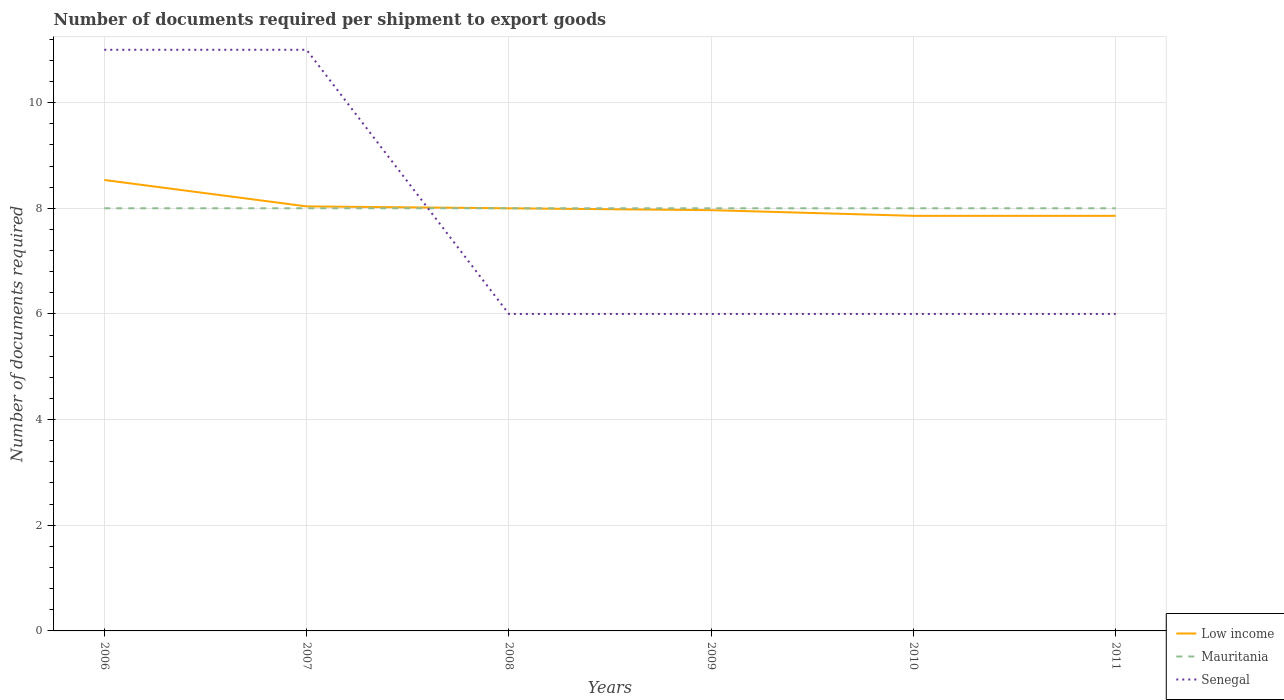How many different coloured lines are there?
Offer a very short reply. 3. Is the number of lines equal to the number of legend labels?
Your response must be concise. Yes. In which year was the number of documents required per shipment to export goods in Senegal maximum?
Provide a succinct answer. 2008. What is the total number of documents required per shipment to export goods in Low income in the graph?
Your answer should be very brief. 0.18. What is the difference between the highest and the second highest number of documents required per shipment to export goods in Mauritania?
Provide a short and direct response. 0. What is the difference between the highest and the lowest number of documents required per shipment to export goods in Senegal?
Offer a terse response. 2. Is the number of documents required per shipment to export goods in Low income strictly greater than the number of documents required per shipment to export goods in Senegal over the years?
Your response must be concise. No. Are the values on the major ticks of Y-axis written in scientific E-notation?
Keep it short and to the point. No. Does the graph contain any zero values?
Your response must be concise. No. Where does the legend appear in the graph?
Offer a very short reply. Bottom right. How are the legend labels stacked?
Ensure brevity in your answer.  Vertical. What is the title of the graph?
Make the answer very short. Number of documents required per shipment to export goods. Does "Luxembourg" appear as one of the legend labels in the graph?
Offer a terse response. No. What is the label or title of the X-axis?
Ensure brevity in your answer.  Years. What is the label or title of the Y-axis?
Keep it short and to the point. Number of documents required. What is the Number of documents required of Low income in 2006?
Provide a succinct answer. 8.54. What is the Number of documents required in Mauritania in 2006?
Offer a terse response. 8. What is the Number of documents required of Senegal in 2006?
Your answer should be compact. 11. What is the Number of documents required in Low income in 2007?
Provide a short and direct response. 8.04. What is the Number of documents required in Mauritania in 2008?
Your answer should be very brief. 8. What is the Number of documents required of Low income in 2009?
Offer a terse response. 7.96. What is the Number of documents required in Mauritania in 2009?
Offer a terse response. 8. What is the Number of documents required in Low income in 2010?
Ensure brevity in your answer.  7.86. What is the Number of documents required of Senegal in 2010?
Keep it short and to the point. 6. What is the Number of documents required in Low income in 2011?
Offer a terse response. 7.86. Across all years, what is the maximum Number of documents required in Low income?
Offer a very short reply. 8.54. Across all years, what is the maximum Number of documents required of Mauritania?
Your answer should be compact. 8. Across all years, what is the minimum Number of documents required of Low income?
Offer a very short reply. 7.86. Across all years, what is the minimum Number of documents required of Mauritania?
Your answer should be compact. 8. What is the total Number of documents required of Low income in the graph?
Make the answer very short. 48.25. What is the difference between the Number of documents required of Mauritania in 2006 and that in 2007?
Make the answer very short. 0. What is the difference between the Number of documents required in Senegal in 2006 and that in 2007?
Your answer should be compact. 0. What is the difference between the Number of documents required in Low income in 2006 and that in 2008?
Your answer should be compact. 0.54. What is the difference between the Number of documents required of Mauritania in 2006 and that in 2009?
Give a very brief answer. 0. What is the difference between the Number of documents required of Senegal in 2006 and that in 2009?
Your answer should be very brief. 5. What is the difference between the Number of documents required of Low income in 2006 and that in 2010?
Offer a very short reply. 0.68. What is the difference between the Number of documents required in Senegal in 2006 and that in 2010?
Give a very brief answer. 5. What is the difference between the Number of documents required in Low income in 2006 and that in 2011?
Give a very brief answer. 0.68. What is the difference between the Number of documents required in Mauritania in 2006 and that in 2011?
Offer a very short reply. 0. What is the difference between the Number of documents required in Low income in 2007 and that in 2008?
Keep it short and to the point. 0.04. What is the difference between the Number of documents required of Low income in 2007 and that in 2009?
Your answer should be compact. 0.07. What is the difference between the Number of documents required in Mauritania in 2007 and that in 2009?
Your answer should be compact. 0. What is the difference between the Number of documents required in Senegal in 2007 and that in 2009?
Your answer should be very brief. 5. What is the difference between the Number of documents required in Low income in 2007 and that in 2010?
Offer a terse response. 0.18. What is the difference between the Number of documents required of Mauritania in 2007 and that in 2010?
Your response must be concise. 0. What is the difference between the Number of documents required of Low income in 2007 and that in 2011?
Offer a terse response. 0.18. What is the difference between the Number of documents required in Senegal in 2007 and that in 2011?
Offer a very short reply. 5. What is the difference between the Number of documents required in Low income in 2008 and that in 2009?
Your response must be concise. 0.04. What is the difference between the Number of documents required of Low income in 2008 and that in 2010?
Your answer should be very brief. 0.14. What is the difference between the Number of documents required of Mauritania in 2008 and that in 2010?
Ensure brevity in your answer.  0. What is the difference between the Number of documents required in Senegal in 2008 and that in 2010?
Your answer should be very brief. 0. What is the difference between the Number of documents required of Low income in 2008 and that in 2011?
Provide a succinct answer. 0.14. What is the difference between the Number of documents required of Senegal in 2008 and that in 2011?
Make the answer very short. 0. What is the difference between the Number of documents required of Low income in 2009 and that in 2010?
Offer a terse response. 0.11. What is the difference between the Number of documents required in Mauritania in 2009 and that in 2010?
Ensure brevity in your answer.  0. What is the difference between the Number of documents required in Low income in 2009 and that in 2011?
Provide a succinct answer. 0.11. What is the difference between the Number of documents required in Mauritania in 2009 and that in 2011?
Ensure brevity in your answer.  0. What is the difference between the Number of documents required of Low income in 2010 and that in 2011?
Your answer should be very brief. 0. What is the difference between the Number of documents required in Mauritania in 2010 and that in 2011?
Give a very brief answer. 0. What is the difference between the Number of documents required in Low income in 2006 and the Number of documents required in Mauritania in 2007?
Make the answer very short. 0.54. What is the difference between the Number of documents required of Low income in 2006 and the Number of documents required of Senegal in 2007?
Give a very brief answer. -2.46. What is the difference between the Number of documents required of Mauritania in 2006 and the Number of documents required of Senegal in 2007?
Offer a terse response. -3. What is the difference between the Number of documents required of Low income in 2006 and the Number of documents required of Mauritania in 2008?
Offer a very short reply. 0.54. What is the difference between the Number of documents required in Low income in 2006 and the Number of documents required in Senegal in 2008?
Offer a terse response. 2.54. What is the difference between the Number of documents required in Low income in 2006 and the Number of documents required in Mauritania in 2009?
Ensure brevity in your answer.  0.54. What is the difference between the Number of documents required of Low income in 2006 and the Number of documents required of Senegal in 2009?
Provide a succinct answer. 2.54. What is the difference between the Number of documents required of Low income in 2006 and the Number of documents required of Mauritania in 2010?
Keep it short and to the point. 0.54. What is the difference between the Number of documents required of Low income in 2006 and the Number of documents required of Senegal in 2010?
Make the answer very short. 2.54. What is the difference between the Number of documents required in Low income in 2006 and the Number of documents required in Mauritania in 2011?
Your response must be concise. 0.54. What is the difference between the Number of documents required in Low income in 2006 and the Number of documents required in Senegal in 2011?
Your answer should be compact. 2.54. What is the difference between the Number of documents required in Low income in 2007 and the Number of documents required in Mauritania in 2008?
Your answer should be very brief. 0.04. What is the difference between the Number of documents required in Low income in 2007 and the Number of documents required in Senegal in 2008?
Ensure brevity in your answer.  2.04. What is the difference between the Number of documents required of Low income in 2007 and the Number of documents required of Mauritania in 2009?
Offer a terse response. 0.04. What is the difference between the Number of documents required of Low income in 2007 and the Number of documents required of Senegal in 2009?
Offer a terse response. 2.04. What is the difference between the Number of documents required in Low income in 2007 and the Number of documents required in Mauritania in 2010?
Make the answer very short. 0.04. What is the difference between the Number of documents required in Low income in 2007 and the Number of documents required in Senegal in 2010?
Offer a terse response. 2.04. What is the difference between the Number of documents required of Mauritania in 2007 and the Number of documents required of Senegal in 2010?
Give a very brief answer. 2. What is the difference between the Number of documents required of Low income in 2007 and the Number of documents required of Mauritania in 2011?
Keep it short and to the point. 0.04. What is the difference between the Number of documents required of Low income in 2007 and the Number of documents required of Senegal in 2011?
Your answer should be very brief. 2.04. What is the difference between the Number of documents required of Mauritania in 2007 and the Number of documents required of Senegal in 2011?
Keep it short and to the point. 2. What is the difference between the Number of documents required in Mauritania in 2008 and the Number of documents required in Senegal in 2009?
Keep it short and to the point. 2. What is the difference between the Number of documents required of Low income in 2008 and the Number of documents required of Mauritania in 2010?
Ensure brevity in your answer.  0. What is the difference between the Number of documents required in Low income in 2008 and the Number of documents required in Senegal in 2010?
Your answer should be compact. 2. What is the difference between the Number of documents required of Low income in 2008 and the Number of documents required of Senegal in 2011?
Provide a succinct answer. 2. What is the difference between the Number of documents required in Low income in 2009 and the Number of documents required in Mauritania in 2010?
Make the answer very short. -0.04. What is the difference between the Number of documents required of Low income in 2009 and the Number of documents required of Senegal in 2010?
Provide a succinct answer. 1.96. What is the difference between the Number of documents required of Low income in 2009 and the Number of documents required of Mauritania in 2011?
Your answer should be very brief. -0.04. What is the difference between the Number of documents required in Low income in 2009 and the Number of documents required in Senegal in 2011?
Offer a very short reply. 1.96. What is the difference between the Number of documents required in Low income in 2010 and the Number of documents required in Mauritania in 2011?
Give a very brief answer. -0.14. What is the difference between the Number of documents required in Low income in 2010 and the Number of documents required in Senegal in 2011?
Provide a succinct answer. 1.86. What is the difference between the Number of documents required of Mauritania in 2010 and the Number of documents required of Senegal in 2011?
Your response must be concise. 2. What is the average Number of documents required of Low income per year?
Offer a very short reply. 8.04. What is the average Number of documents required of Senegal per year?
Your response must be concise. 7.67. In the year 2006, what is the difference between the Number of documents required in Low income and Number of documents required in Mauritania?
Keep it short and to the point. 0.54. In the year 2006, what is the difference between the Number of documents required in Low income and Number of documents required in Senegal?
Keep it short and to the point. -2.46. In the year 2007, what is the difference between the Number of documents required of Low income and Number of documents required of Mauritania?
Offer a very short reply. 0.04. In the year 2007, what is the difference between the Number of documents required in Low income and Number of documents required in Senegal?
Give a very brief answer. -2.96. In the year 2007, what is the difference between the Number of documents required in Mauritania and Number of documents required in Senegal?
Your answer should be very brief. -3. In the year 2008, what is the difference between the Number of documents required of Low income and Number of documents required of Senegal?
Provide a succinct answer. 2. In the year 2009, what is the difference between the Number of documents required in Low income and Number of documents required in Mauritania?
Provide a succinct answer. -0.04. In the year 2009, what is the difference between the Number of documents required in Low income and Number of documents required in Senegal?
Provide a short and direct response. 1.96. In the year 2010, what is the difference between the Number of documents required of Low income and Number of documents required of Mauritania?
Ensure brevity in your answer.  -0.14. In the year 2010, what is the difference between the Number of documents required in Low income and Number of documents required in Senegal?
Provide a succinct answer. 1.86. In the year 2010, what is the difference between the Number of documents required of Mauritania and Number of documents required of Senegal?
Keep it short and to the point. 2. In the year 2011, what is the difference between the Number of documents required in Low income and Number of documents required in Mauritania?
Provide a short and direct response. -0.14. In the year 2011, what is the difference between the Number of documents required in Low income and Number of documents required in Senegal?
Ensure brevity in your answer.  1.86. What is the ratio of the Number of documents required of Low income in 2006 to that in 2007?
Offer a terse response. 1.06. What is the ratio of the Number of documents required of Mauritania in 2006 to that in 2007?
Keep it short and to the point. 1. What is the ratio of the Number of documents required in Low income in 2006 to that in 2008?
Offer a terse response. 1.07. What is the ratio of the Number of documents required in Mauritania in 2006 to that in 2008?
Make the answer very short. 1. What is the ratio of the Number of documents required of Senegal in 2006 to that in 2008?
Your response must be concise. 1.83. What is the ratio of the Number of documents required in Low income in 2006 to that in 2009?
Offer a very short reply. 1.07. What is the ratio of the Number of documents required in Mauritania in 2006 to that in 2009?
Provide a succinct answer. 1. What is the ratio of the Number of documents required in Senegal in 2006 to that in 2009?
Offer a very short reply. 1.83. What is the ratio of the Number of documents required of Low income in 2006 to that in 2010?
Offer a terse response. 1.09. What is the ratio of the Number of documents required of Mauritania in 2006 to that in 2010?
Give a very brief answer. 1. What is the ratio of the Number of documents required of Senegal in 2006 to that in 2010?
Your response must be concise. 1.83. What is the ratio of the Number of documents required of Low income in 2006 to that in 2011?
Offer a terse response. 1.09. What is the ratio of the Number of documents required of Mauritania in 2006 to that in 2011?
Offer a terse response. 1. What is the ratio of the Number of documents required in Senegal in 2006 to that in 2011?
Ensure brevity in your answer.  1.83. What is the ratio of the Number of documents required of Low income in 2007 to that in 2008?
Offer a very short reply. 1. What is the ratio of the Number of documents required of Mauritania in 2007 to that in 2008?
Offer a terse response. 1. What is the ratio of the Number of documents required in Senegal in 2007 to that in 2008?
Offer a terse response. 1.83. What is the ratio of the Number of documents required of Low income in 2007 to that in 2009?
Give a very brief answer. 1.01. What is the ratio of the Number of documents required of Senegal in 2007 to that in 2009?
Make the answer very short. 1.83. What is the ratio of the Number of documents required in Low income in 2007 to that in 2010?
Offer a terse response. 1.02. What is the ratio of the Number of documents required in Senegal in 2007 to that in 2010?
Keep it short and to the point. 1.83. What is the ratio of the Number of documents required of Low income in 2007 to that in 2011?
Your response must be concise. 1.02. What is the ratio of the Number of documents required in Senegal in 2007 to that in 2011?
Offer a very short reply. 1.83. What is the ratio of the Number of documents required of Senegal in 2008 to that in 2009?
Provide a succinct answer. 1. What is the ratio of the Number of documents required in Low income in 2008 to that in 2010?
Your answer should be compact. 1.02. What is the ratio of the Number of documents required of Senegal in 2008 to that in 2010?
Your response must be concise. 1. What is the ratio of the Number of documents required in Low income in 2008 to that in 2011?
Make the answer very short. 1.02. What is the ratio of the Number of documents required of Mauritania in 2008 to that in 2011?
Your answer should be compact. 1. What is the ratio of the Number of documents required of Low income in 2009 to that in 2010?
Your answer should be compact. 1.01. What is the ratio of the Number of documents required in Mauritania in 2009 to that in 2010?
Provide a succinct answer. 1. What is the ratio of the Number of documents required in Senegal in 2009 to that in 2010?
Ensure brevity in your answer.  1. What is the ratio of the Number of documents required in Low income in 2009 to that in 2011?
Give a very brief answer. 1.01. What is the ratio of the Number of documents required of Mauritania in 2009 to that in 2011?
Keep it short and to the point. 1. What is the ratio of the Number of documents required of Mauritania in 2010 to that in 2011?
Provide a short and direct response. 1. What is the ratio of the Number of documents required in Senegal in 2010 to that in 2011?
Make the answer very short. 1. What is the difference between the highest and the second highest Number of documents required of Low income?
Your response must be concise. 0.5. What is the difference between the highest and the second highest Number of documents required in Mauritania?
Ensure brevity in your answer.  0. What is the difference between the highest and the second highest Number of documents required of Senegal?
Provide a short and direct response. 0. What is the difference between the highest and the lowest Number of documents required of Low income?
Make the answer very short. 0.68. What is the difference between the highest and the lowest Number of documents required in Mauritania?
Offer a terse response. 0. 